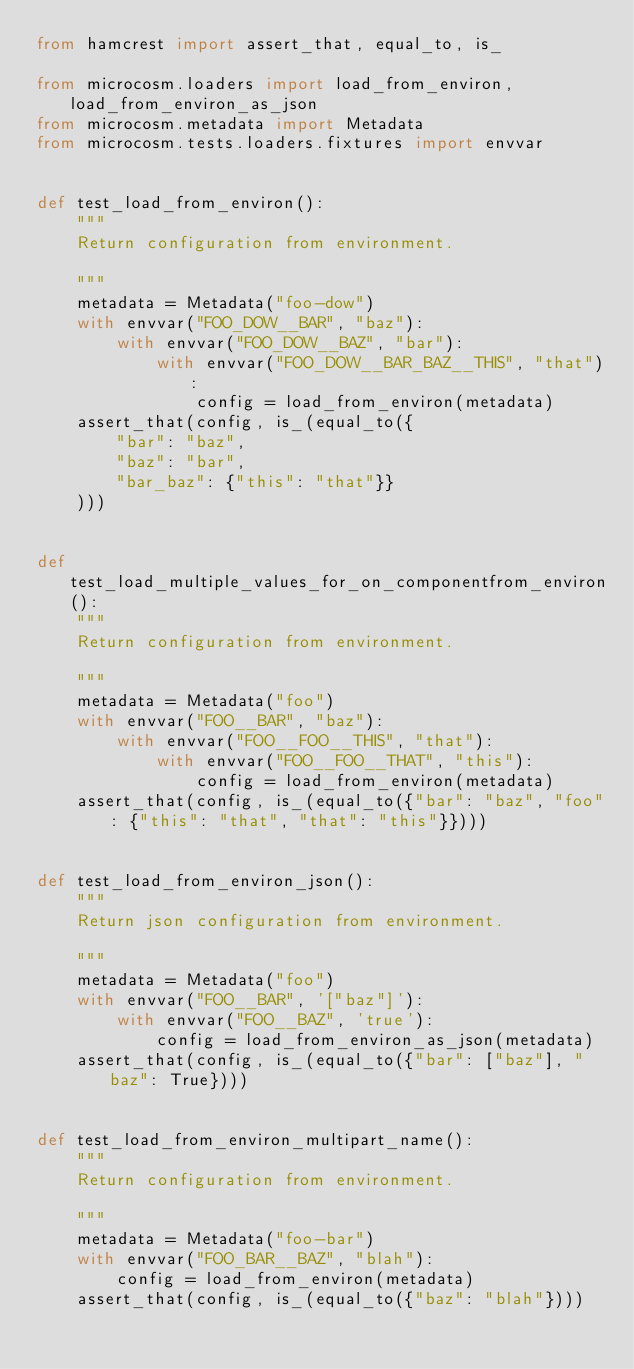Convert code to text. <code><loc_0><loc_0><loc_500><loc_500><_Python_>from hamcrest import assert_that, equal_to, is_

from microcosm.loaders import load_from_environ, load_from_environ_as_json
from microcosm.metadata import Metadata
from microcosm.tests.loaders.fixtures import envvar


def test_load_from_environ():
    """
    Return configuration from environment.

    """
    metadata = Metadata("foo-dow")
    with envvar("FOO_DOW__BAR", "baz"):
        with envvar("FOO_DOW__BAZ", "bar"):
            with envvar("FOO_DOW__BAR_BAZ__THIS", "that"):
                config = load_from_environ(metadata)
    assert_that(config, is_(equal_to({
        "bar": "baz",
        "baz": "bar",
        "bar_baz": {"this": "that"}}
    )))


def test_load_multiple_values_for_on_componentfrom_environ():
    """
    Return configuration from environment.

    """
    metadata = Metadata("foo")
    with envvar("FOO__BAR", "baz"):
        with envvar("FOO__FOO__THIS", "that"):
            with envvar("FOO__FOO__THAT", "this"):
                config = load_from_environ(metadata)
    assert_that(config, is_(equal_to({"bar": "baz", "foo": {"this": "that", "that": "this"}})))


def test_load_from_environ_json():
    """
    Return json configuration from environment.

    """
    metadata = Metadata("foo")
    with envvar("FOO__BAR", '["baz"]'):
        with envvar("FOO__BAZ", 'true'):
            config = load_from_environ_as_json(metadata)
    assert_that(config, is_(equal_to({"bar": ["baz"], "baz": True})))


def test_load_from_environ_multipart_name():
    """
    Return configuration from environment.

    """
    metadata = Metadata("foo-bar")
    with envvar("FOO_BAR__BAZ", "blah"):
        config = load_from_environ(metadata)
    assert_that(config, is_(equal_to({"baz": "blah"})))
</code> 